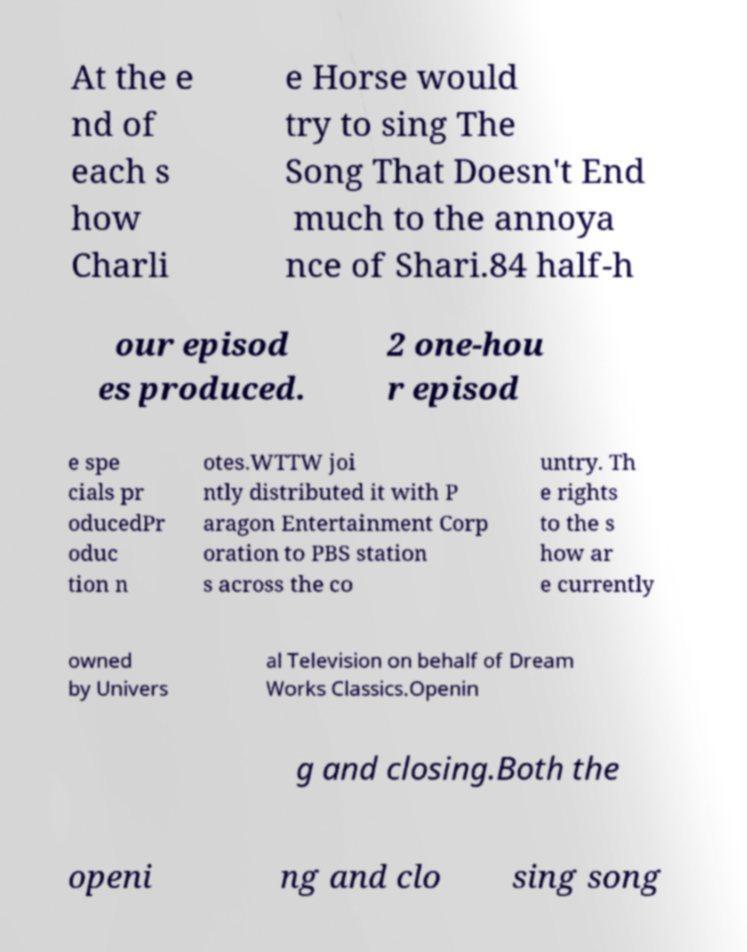Can you accurately transcribe the text from the provided image for me? At the e nd of each s how Charli e Horse would try to sing The Song That Doesn't End much to the annoya nce of Shari.84 half-h our episod es produced. 2 one-hou r episod e spe cials pr oducedPr oduc tion n otes.WTTW joi ntly distributed it with P aragon Entertainment Corp oration to PBS station s across the co untry. Th e rights to the s how ar e currently owned by Univers al Television on behalf of Dream Works Classics.Openin g and closing.Both the openi ng and clo sing song 